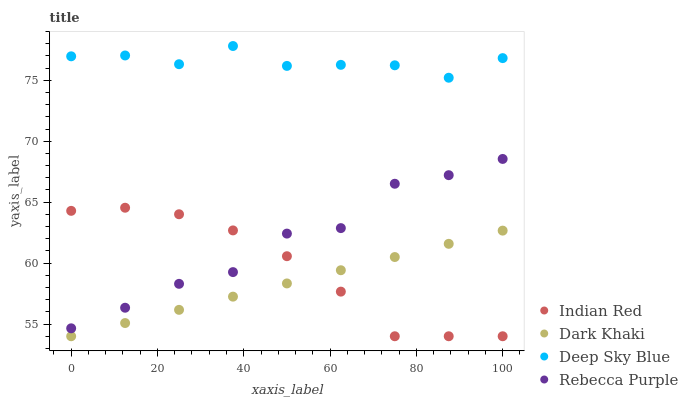Does Dark Khaki have the minimum area under the curve?
Answer yes or no. Yes. Does Deep Sky Blue have the maximum area under the curve?
Answer yes or no. Yes. Does Indian Red have the minimum area under the curve?
Answer yes or no. No. Does Indian Red have the maximum area under the curve?
Answer yes or no. No. Is Dark Khaki the smoothest?
Answer yes or no. Yes. Is Rebecca Purple the roughest?
Answer yes or no. Yes. Is Deep Sky Blue the smoothest?
Answer yes or no. No. Is Deep Sky Blue the roughest?
Answer yes or no. No. Does Dark Khaki have the lowest value?
Answer yes or no. Yes. Does Deep Sky Blue have the lowest value?
Answer yes or no. No. Does Deep Sky Blue have the highest value?
Answer yes or no. Yes. Does Indian Red have the highest value?
Answer yes or no. No. Is Rebecca Purple less than Deep Sky Blue?
Answer yes or no. Yes. Is Deep Sky Blue greater than Dark Khaki?
Answer yes or no. Yes. Does Indian Red intersect Dark Khaki?
Answer yes or no. Yes. Is Indian Red less than Dark Khaki?
Answer yes or no. No. Is Indian Red greater than Dark Khaki?
Answer yes or no. No. Does Rebecca Purple intersect Deep Sky Blue?
Answer yes or no. No. 